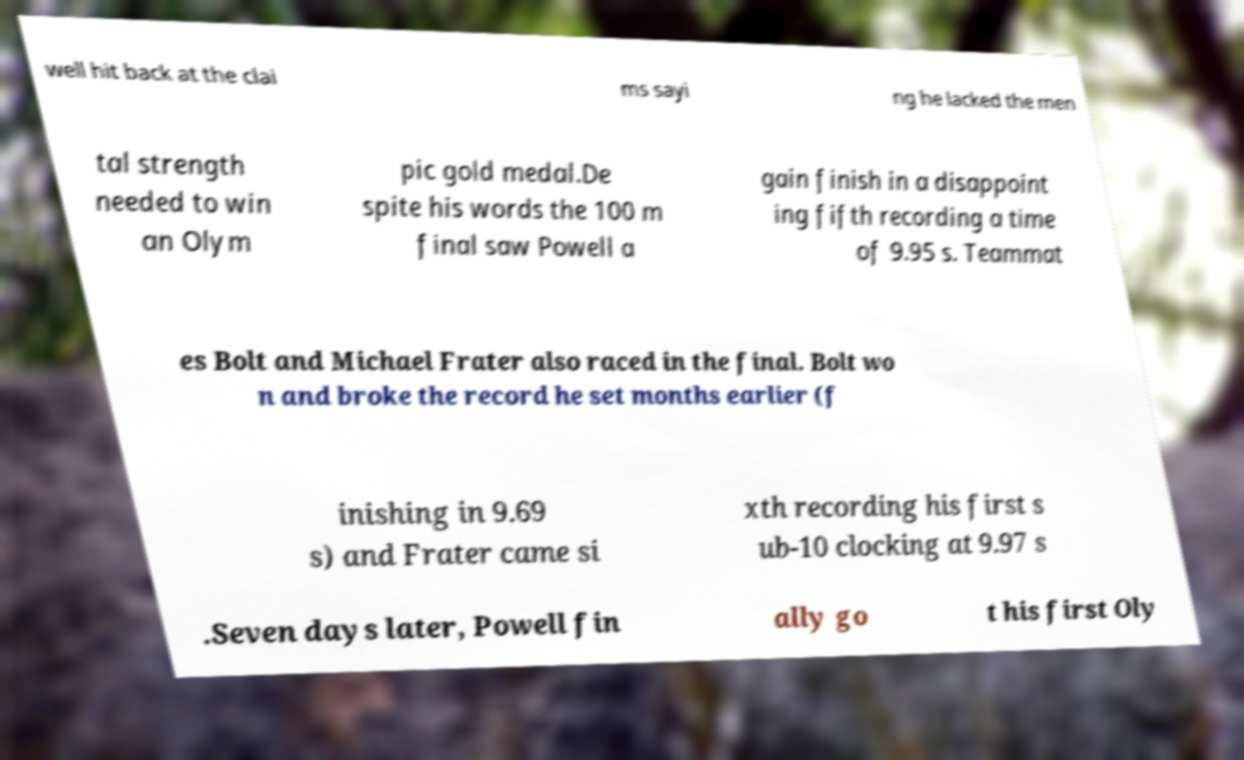Please read and relay the text visible in this image. What does it say? well hit back at the clai ms sayi ng he lacked the men tal strength needed to win an Olym pic gold medal.De spite his words the 100 m final saw Powell a gain finish in a disappoint ing fifth recording a time of 9.95 s. Teammat es Bolt and Michael Frater also raced in the final. Bolt wo n and broke the record he set months earlier (f inishing in 9.69 s) and Frater came si xth recording his first s ub-10 clocking at 9.97 s .Seven days later, Powell fin ally go t his first Oly 